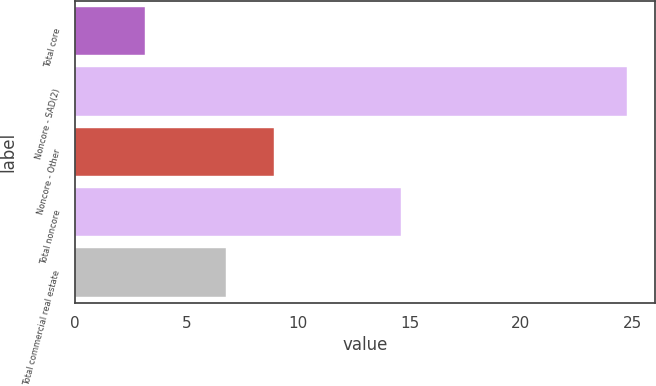<chart> <loc_0><loc_0><loc_500><loc_500><bar_chart><fcel>Total core<fcel>Noncore - SAD(2)<fcel>Noncore - Other<fcel>Total noncore<fcel>Total commercial real estate<nl><fcel>3.14<fcel>24.76<fcel>8.94<fcel>14.61<fcel>6.78<nl></chart> 